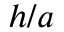<formula> <loc_0><loc_0><loc_500><loc_500>h / a</formula> 